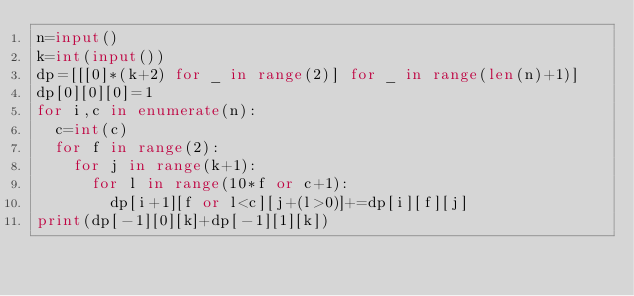Convert code to text. <code><loc_0><loc_0><loc_500><loc_500><_Python_>n=input()
k=int(input())
dp=[[[0]*(k+2) for _ in range(2)] for _ in range(len(n)+1)]
dp[0][0][0]=1
for i,c in enumerate(n):
	c=int(c)
	for f in range(2):
		for j in range(k+1):
			for l in range(10*f or c+1):
				dp[i+1][f or l<c][j+(l>0)]+=dp[i][f][j]
print(dp[-1][0][k]+dp[-1][1][k])</code> 